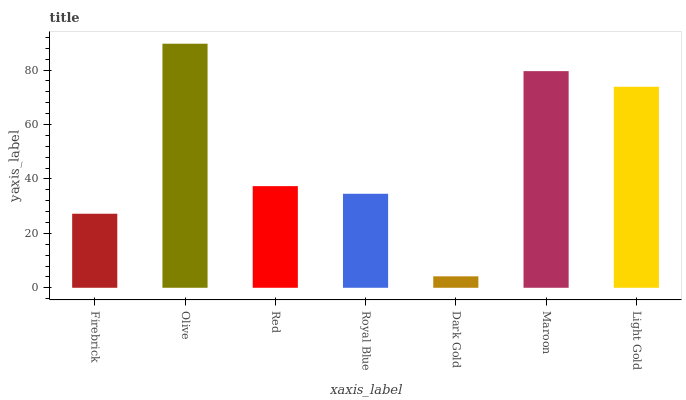Is Dark Gold the minimum?
Answer yes or no. Yes. Is Olive the maximum?
Answer yes or no. Yes. Is Red the minimum?
Answer yes or no. No. Is Red the maximum?
Answer yes or no. No. Is Olive greater than Red?
Answer yes or no. Yes. Is Red less than Olive?
Answer yes or no. Yes. Is Red greater than Olive?
Answer yes or no. No. Is Olive less than Red?
Answer yes or no. No. Is Red the high median?
Answer yes or no. Yes. Is Red the low median?
Answer yes or no. Yes. Is Royal Blue the high median?
Answer yes or no. No. Is Maroon the low median?
Answer yes or no. No. 